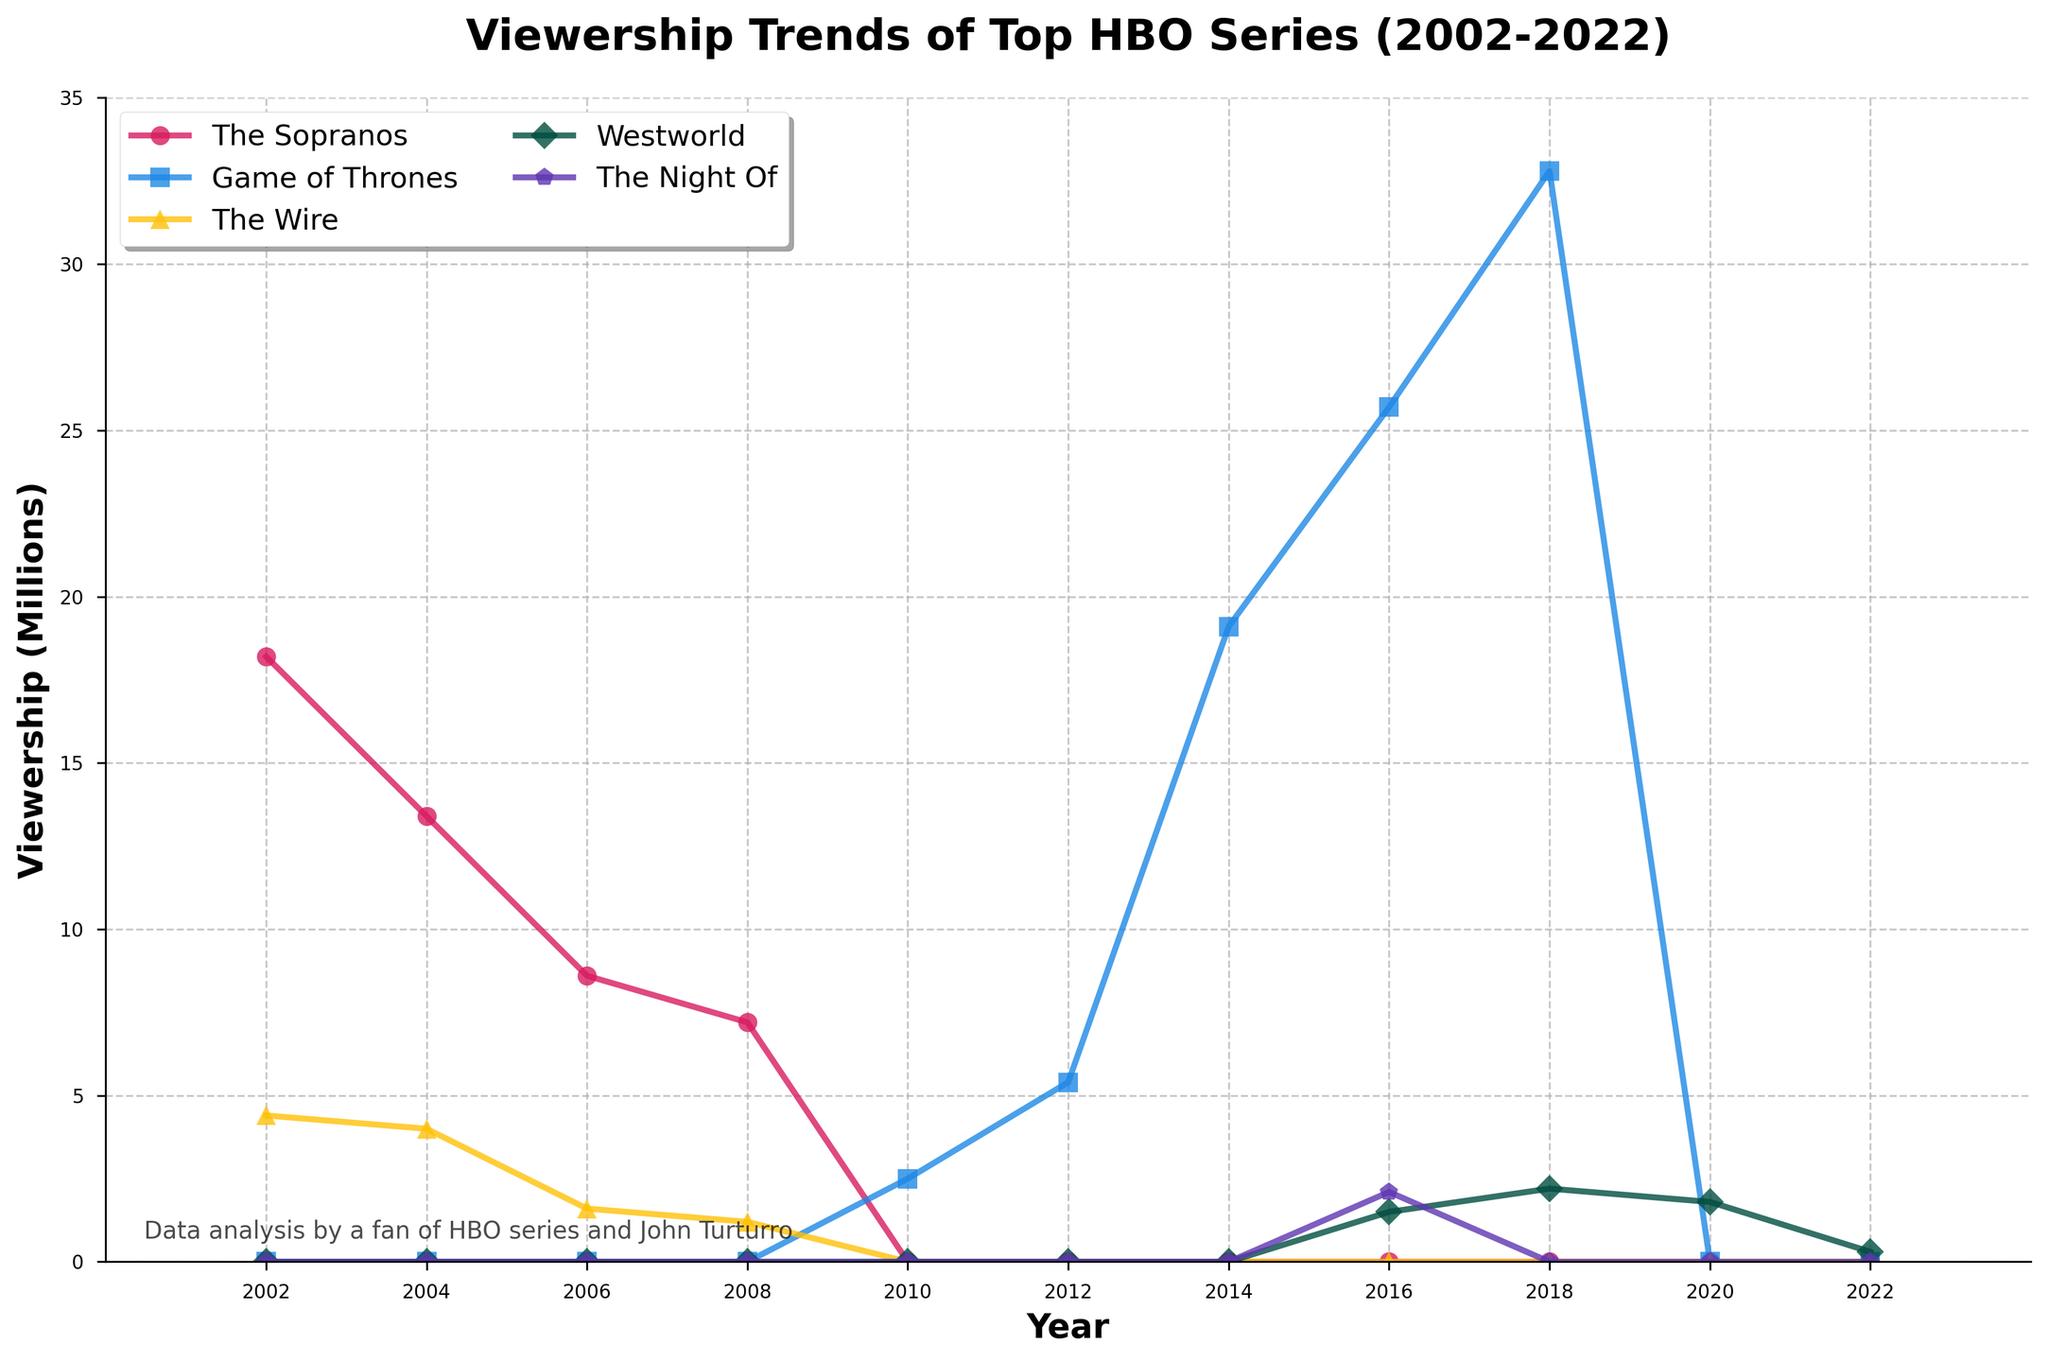What is the viewership trend for The Sopranos from 2002 to 2006? The viewership for The Sopranos decreased consistently over the years. In 2002, it was 18.2 million, dropping to 13.4 million in 2004 and finally reaching 8.6 million in 2006.
Answer: Decreasing Which year did Game of Thrones have the highest viewership? Game of Thrones had its highest viewership in 2018, where the viewership reached 32.8 million.
Answer: 2018 How does the maximum viewership of Westworld compare to The Wire? Westworld reached its highest viewership at 2.2 million in 2018, while The Wire's highest was 4.4 million in 2002. Therefore, The Wire had a higher maximum viewership than Westworld.
Answer: The Wire had a higher max In which year did The Night Of start showing on the chart? The Night Of started appearing on the chart in 2016 with a viewership of 2.1 million.
Answer: 2016 What is the sum of viewership for The Sopranos in 2002 and Game of Thrones in 2016? The Sopranos had 18.2 million viewers in 2002, and Game of Thrones had 25.7 million in 2016. Adding these gives: 18.2 + 25.7 = 43.9 million.
Answer: 43.9 million From 2002 to 2022, which HBO series experienced the largest increase in viewership? Game of Thrones experienced the largest increase, growing from 2.5 million in 2010 to 32.8 million in 2018, which is an increase of 30.3 million.
Answer: Game of Thrones What is the average viewership of The Night Of across the years it appeared in the chart? The Night Of has viewership data for 2016 (2.1 million) and 2018 (0 million). The average is calculated as (2.1 + 0)/2 = 1.05 million.
Answer: 1.05 million Which series had zero viewership in 2012, and what could be the potential reason? All series except for Game of Thrones had zero viewership in 2012. Potentially, these series either had not been released yet or were no longer airing.
Answer: The Sopranos, The Wire, Westworld, The Night Of How did the viewership of The Wire compare to that of The Sopranos in 2004? In 2004, The Sopranos had a viewership of 13.4 million while The Wire had a viewership of 4.0 million.
Answer: The Sopranos had higher viewership What is the color used to represent the series The Night Of in the chart? The color used to represent The Night Of is purple.
Answer: Purple 